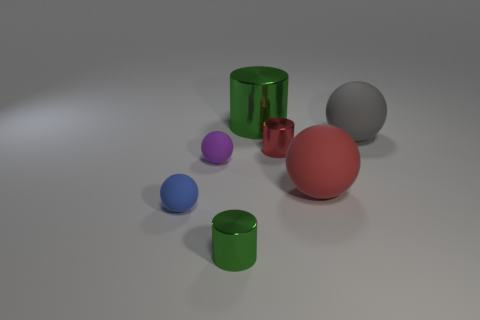What is the color of the small metal thing on the right side of the green shiny cylinder that is behind the gray object?
Your response must be concise. Red. What number of big objects are metal cylinders or blue spheres?
Offer a terse response. 1. There is a blue thing that is the same shape as the big red thing; what is its material?
Keep it short and to the point. Rubber. Is there any other thing that has the same material as the tiny purple thing?
Provide a short and direct response. Yes. The big metallic object has what color?
Provide a succinct answer. Green. There is a green metallic cylinder behind the tiny purple rubber sphere; what number of purple spheres are in front of it?
Give a very brief answer. 1. There is a metallic cylinder that is in front of the gray object and behind the small green shiny cylinder; what size is it?
Keep it short and to the point. Small. What material is the small sphere to the right of the small blue thing?
Offer a very short reply. Rubber. Are there any other purple matte things of the same shape as the tiny purple object?
Offer a very short reply. No. What number of other matte things have the same shape as the blue object?
Provide a short and direct response. 3. 